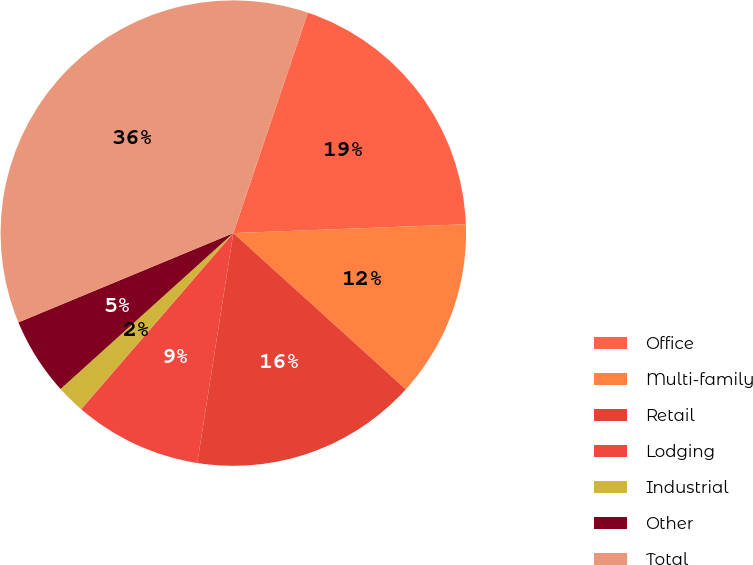<chart> <loc_0><loc_0><loc_500><loc_500><pie_chart><fcel>Office<fcel>Multi-family<fcel>Retail<fcel>Lodging<fcel>Industrial<fcel>Other<fcel>Total<nl><fcel>19.21%<fcel>12.32%<fcel>15.76%<fcel>8.87%<fcel>1.97%<fcel>5.42%<fcel>36.45%<nl></chart> 